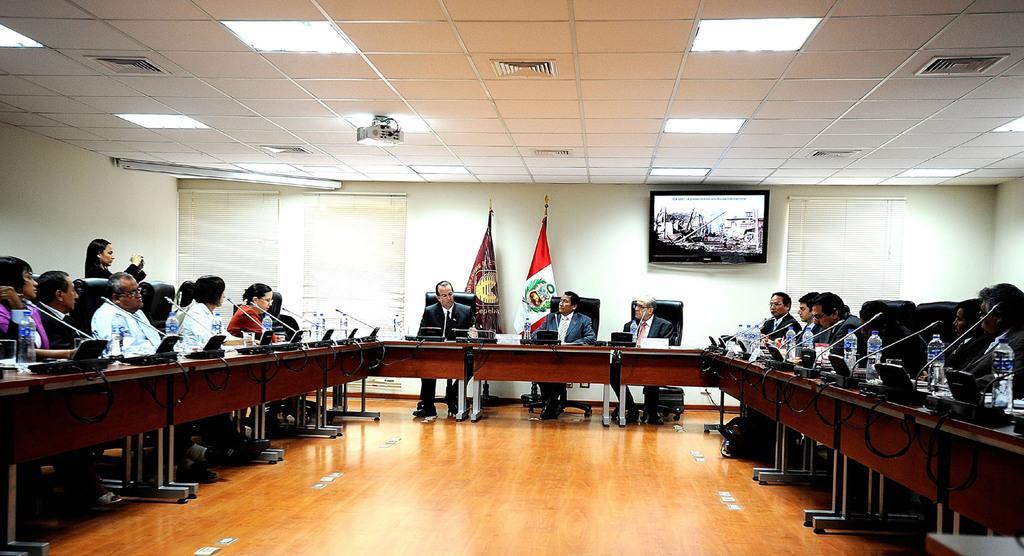Describe this image in one or two sentences. There are group of people sitting on the chairs in an order. This is a desk with miles and water bottles placed on it. These are the two bags hanging to the pole. This is the screen attached to the wall. This is the ceiling light at the rooftop. Here is the woman standing. I can see a projector attached to the rooftop. 